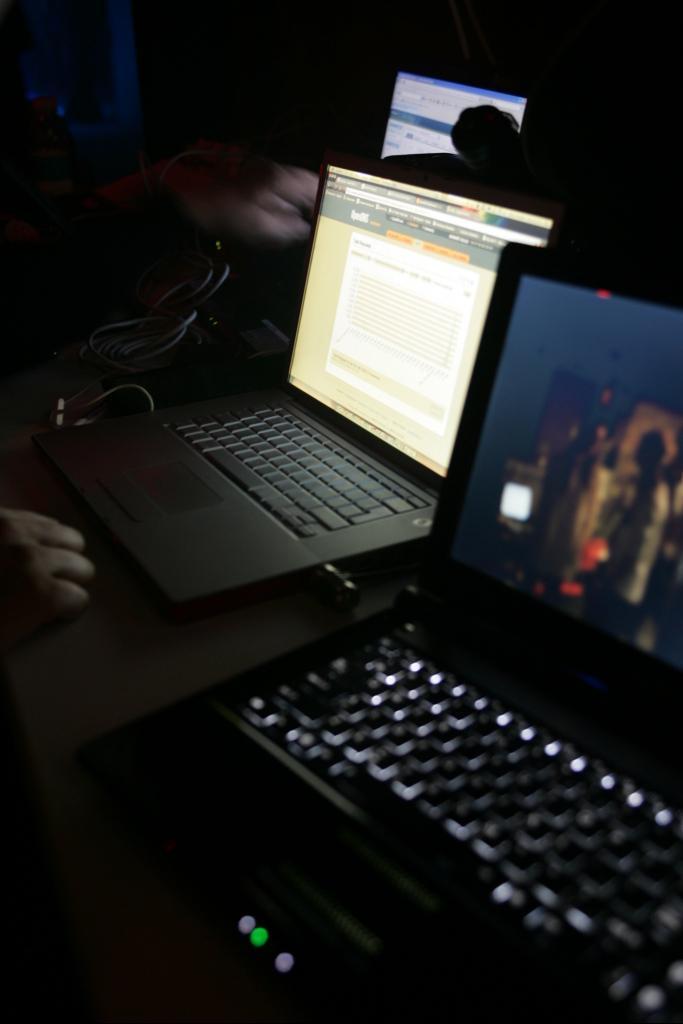Describe this image in one or two sentences. In this image we can see two laptop. Left side of the image human hand is there. Background of the image one monitor screen is present. 